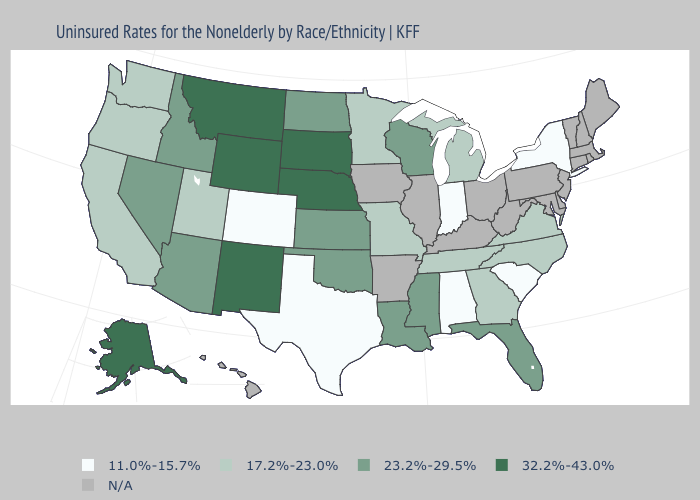Which states have the lowest value in the USA?
Answer briefly. Alabama, Colorado, Indiana, New York, South Carolina, Texas. Does Texas have the lowest value in the USA?
Quick response, please. Yes. What is the lowest value in states that border Ohio?
Answer briefly. 11.0%-15.7%. What is the lowest value in the West?
Give a very brief answer. 11.0%-15.7%. What is the value of Tennessee?
Concise answer only. 17.2%-23.0%. Name the states that have a value in the range N/A?
Give a very brief answer. Arkansas, Connecticut, Delaware, Hawaii, Illinois, Iowa, Kentucky, Maine, Maryland, Massachusetts, New Hampshire, New Jersey, Ohio, Pennsylvania, Rhode Island, Vermont, West Virginia. How many symbols are there in the legend?
Concise answer only. 5. Which states have the highest value in the USA?
Quick response, please. Alaska, Montana, Nebraska, New Mexico, South Dakota, Wyoming. What is the lowest value in the Northeast?
Concise answer only. 11.0%-15.7%. Name the states that have a value in the range 17.2%-23.0%?
Write a very short answer. California, Georgia, Michigan, Minnesota, Missouri, North Carolina, Oregon, Tennessee, Utah, Virginia, Washington. Name the states that have a value in the range N/A?
Give a very brief answer. Arkansas, Connecticut, Delaware, Hawaii, Illinois, Iowa, Kentucky, Maine, Maryland, Massachusetts, New Hampshire, New Jersey, Ohio, Pennsylvania, Rhode Island, Vermont, West Virginia. 